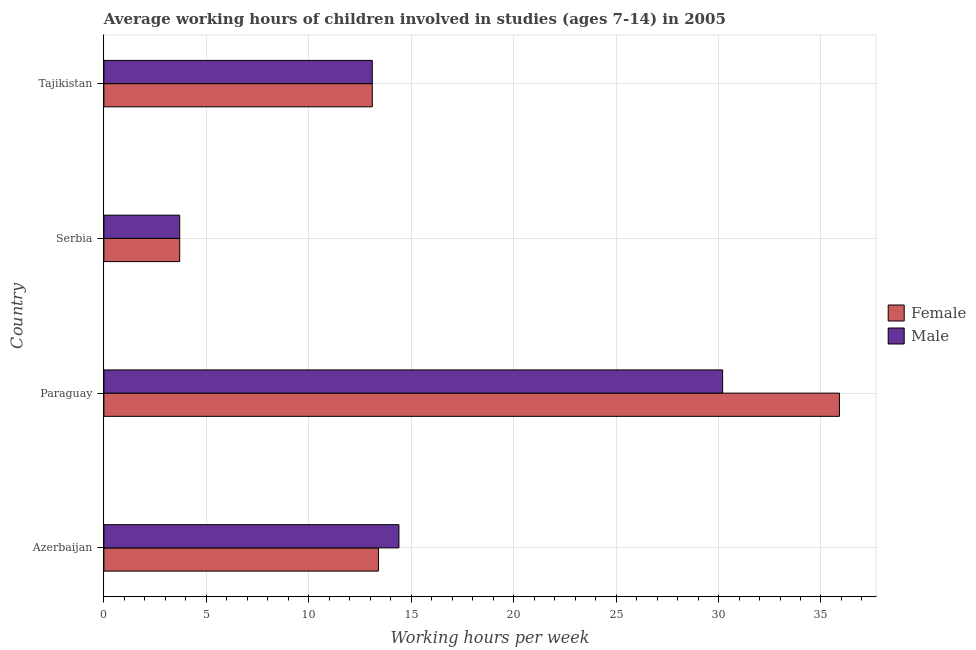Are the number of bars per tick equal to the number of legend labels?
Keep it short and to the point. Yes. How many bars are there on the 3rd tick from the top?
Provide a succinct answer. 2. How many bars are there on the 1st tick from the bottom?
Your response must be concise. 2. What is the label of the 3rd group of bars from the top?
Ensure brevity in your answer.  Paraguay. Across all countries, what is the maximum average working hour of female children?
Make the answer very short. 35.9. In which country was the average working hour of female children maximum?
Your response must be concise. Paraguay. In which country was the average working hour of male children minimum?
Provide a short and direct response. Serbia. What is the total average working hour of male children in the graph?
Give a very brief answer. 61.4. What is the average average working hour of female children per country?
Provide a short and direct response. 16.52. What is the difference between the average working hour of female children and average working hour of male children in Tajikistan?
Your response must be concise. 0. What is the ratio of the average working hour of male children in Paraguay to that in Serbia?
Offer a very short reply. 8.16. Is the average working hour of male children in Azerbaijan less than that in Serbia?
Keep it short and to the point. No. How many countries are there in the graph?
Ensure brevity in your answer.  4. Does the graph contain grids?
Your answer should be compact. Yes. How are the legend labels stacked?
Offer a terse response. Vertical. What is the title of the graph?
Offer a terse response. Average working hours of children involved in studies (ages 7-14) in 2005. Does "Young" appear as one of the legend labels in the graph?
Offer a terse response. No. What is the label or title of the X-axis?
Ensure brevity in your answer.  Working hours per week. What is the Working hours per week in Female in Azerbaijan?
Provide a succinct answer. 13.4. What is the Working hours per week of Female in Paraguay?
Ensure brevity in your answer.  35.9. What is the Working hours per week of Male in Paraguay?
Ensure brevity in your answer.  30.2. What is the Working hours per week in Female in Serbia?
Give a very brief answer. 3.7. What is the Working hours per week in Female in Tajikistan?
Your answer should be compact. 13.1. What is the Working hours per week of Male in Tajikistan?
Keep it short and to the point. 13.1. Across all countries, what is the maximum Working hours per week in Female?
Provide a short and direct response. 35.9. Across all countries, what is the maximum Working hours per week in Male?
Offer a very short reply. 30.2. Across all countries, what is the minimum Working hours per week of Female?
Offer a very short reply. 3.7. Across all countries, what is the minimum Working hours per week of Male?
Give a very brief answer. 3.7. What is the total Working hours per week of Female in the graph?
Your response must be concise. 66.1. What is the total Working hours per week in Male in the graph?
Your answer should be very brief. 61.4. What is the difference between the Working hours per week of Female in Azerbaijan and that in Paraguay?
Your answer should be very brief. -22.5. What is the difference between the Working hours per week in Male in Azerbaijan and that in Paraguay?
Provide a succinct answer. -15.8. What is the difference between the Working hours per week of Male in Azerbaijan and that in Serbia?
Provide a short and direct response. 10.7. What is the difference between the Working hours per week of Male in Azerbaijan and that in Tajikistan?
Offer a very short reply. 1.3. What is the difference between the Working hours per week in Female in Paraguay and that in Serbia?
Ensure brevity in your answer.  32.2. What is the difference between the Working hours per week of Female in Paraguay and that in Tajikistan?
Make the answer very short. 22.8. What is the difference between the Working hours per week in Male in Paraguay and that in Tajikistan?
Make the answer very short. 17.1. What is the difference between the Working hours per week of Male in Serbia and that in Tajikistan?
Make the answer very short. -9.4. What is the difference between the Working hours per week in Female in Azerbaijan and the Working hours per week in Male in Paraguay?
Offer a terse response. -16.8. What is the difference between the Working hours per week in Female in Azerbaijan and the Working hours per week in Male in Serbia?
Keep it short and to the point. 9.7. What is the difference between the Working hours per week in Female in Paraguay and the Working hours per week in Male in Serbia?
Your response must be concise. 32.2. What is the difference between the Working hours per week of Female in Paraguay and the Working hours per week of Male in Tajikistan?
Your answer should be very brief. 22.8. What is the average Working hours per week of Female per country?
Give a very brief answer. 16.52. What is the average Working hours per week of Male per country?
Provide a short and direct response. 15.35. What is the difference between the Working hours per week in Female and Working hours per week in Male in Azerbaijan?
Offer a terse response. -1. What is the difference between the Working hours per week of Female and Working hours per week of Male in Serbia?
Provide a short and direct response. 0. What is the ratio of the Working hours per week in Female in Azerbaijan to that in Paraguay?
Your response must be concise. 0.37. What is the ratio of the Working hours per week in Male in Azerbaijan to that in Paraguay?
Your answer should be very brief. 0.48. What is the ratio of the Working hours per week in Female in Azerbaijan to that in Serbia?
Ensure brevity in your answer.  3.62. What is the ratio of the Working hours per week in Male in Azerbaijan to that in Serbia?
Your answer should be very brief. 3.89. What is the ratio of the Working hours per week in Female in Azerbaijan to that in Tajikistan?
Offer a very short reply. 1.02. What is the ratio of the Working hours per week in Male in Azerbaijan to that in Tajikistan?
Provide a short and direct response. 1.1. What is the ratio of the Working hours per week of Female in Paraguay to that in Serbia?
Provide a short and direct response. 9.7. What is the ratio of the Working hours per week of Male in Paraguay to that in Serbia?
Provide a succinct answer. 8.16. What is the ratio of the Working hours per week of Female in Paraguay to that in Tajikistan?
Your answer should be compact. 2.74. What is the ratio of the Working hours per week of Male in Paraguay to that in Tajikistan?
Make the answer very short. 2.31. What is the ratio of the Working hours per week in Female in Serbia to that in Tajikistan?
Offer a very short reply. 0.28. What is the ratio of the Working hours per week in Male in Serbia to that in Tajikistan?
Keep it short and to the point. 0.28. What is the difference between the highest and the second highest Working hours per week in Female?
Provide a short and direct response. 22.5. What is the difference between the highest and the second highest Working hours per week in Male?
Give a very brief answer. 15.8. What is the difference between the highest and the lowest Working hours per week in Female?
Give a very brief answer. 32.2. What is the difference between the highest and the lowest Working hours per week of Male?
Keep it short and to the point. 26.5. 